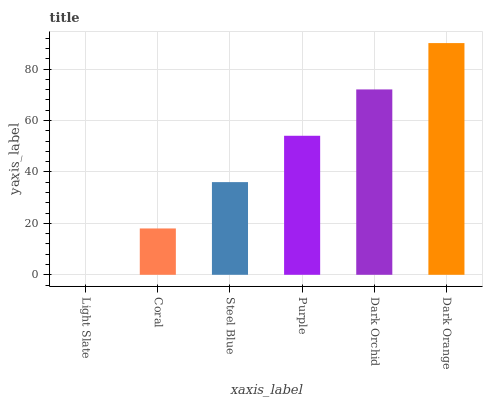Is Light Slate the minimum?
Answer yes or no. Yes. Is Dark Orange the maximum?
Answer yes or no. Yes. Is Coral the minimum?
Answer yes or no. No. Is Coral the maximum?
Answer yes or no. No. Is Coral greater than Light Slate?
Answer yes or no. Yes. Is Light Slate less than Coral?
Answer yes or no. Yes. Is Light Slate greater than Coral?
Answer yes or no. No. Is Coral less than Light Slate?
Answer yes or no. No. Is Purple the high median?
Answer yes or no. Yes. Is Steel Blue the low median?
Answer yes or no. Yes. Is Coral the high median?
Answer yes or no. No. Is Coral the low median?
Answer yes or no. No. 